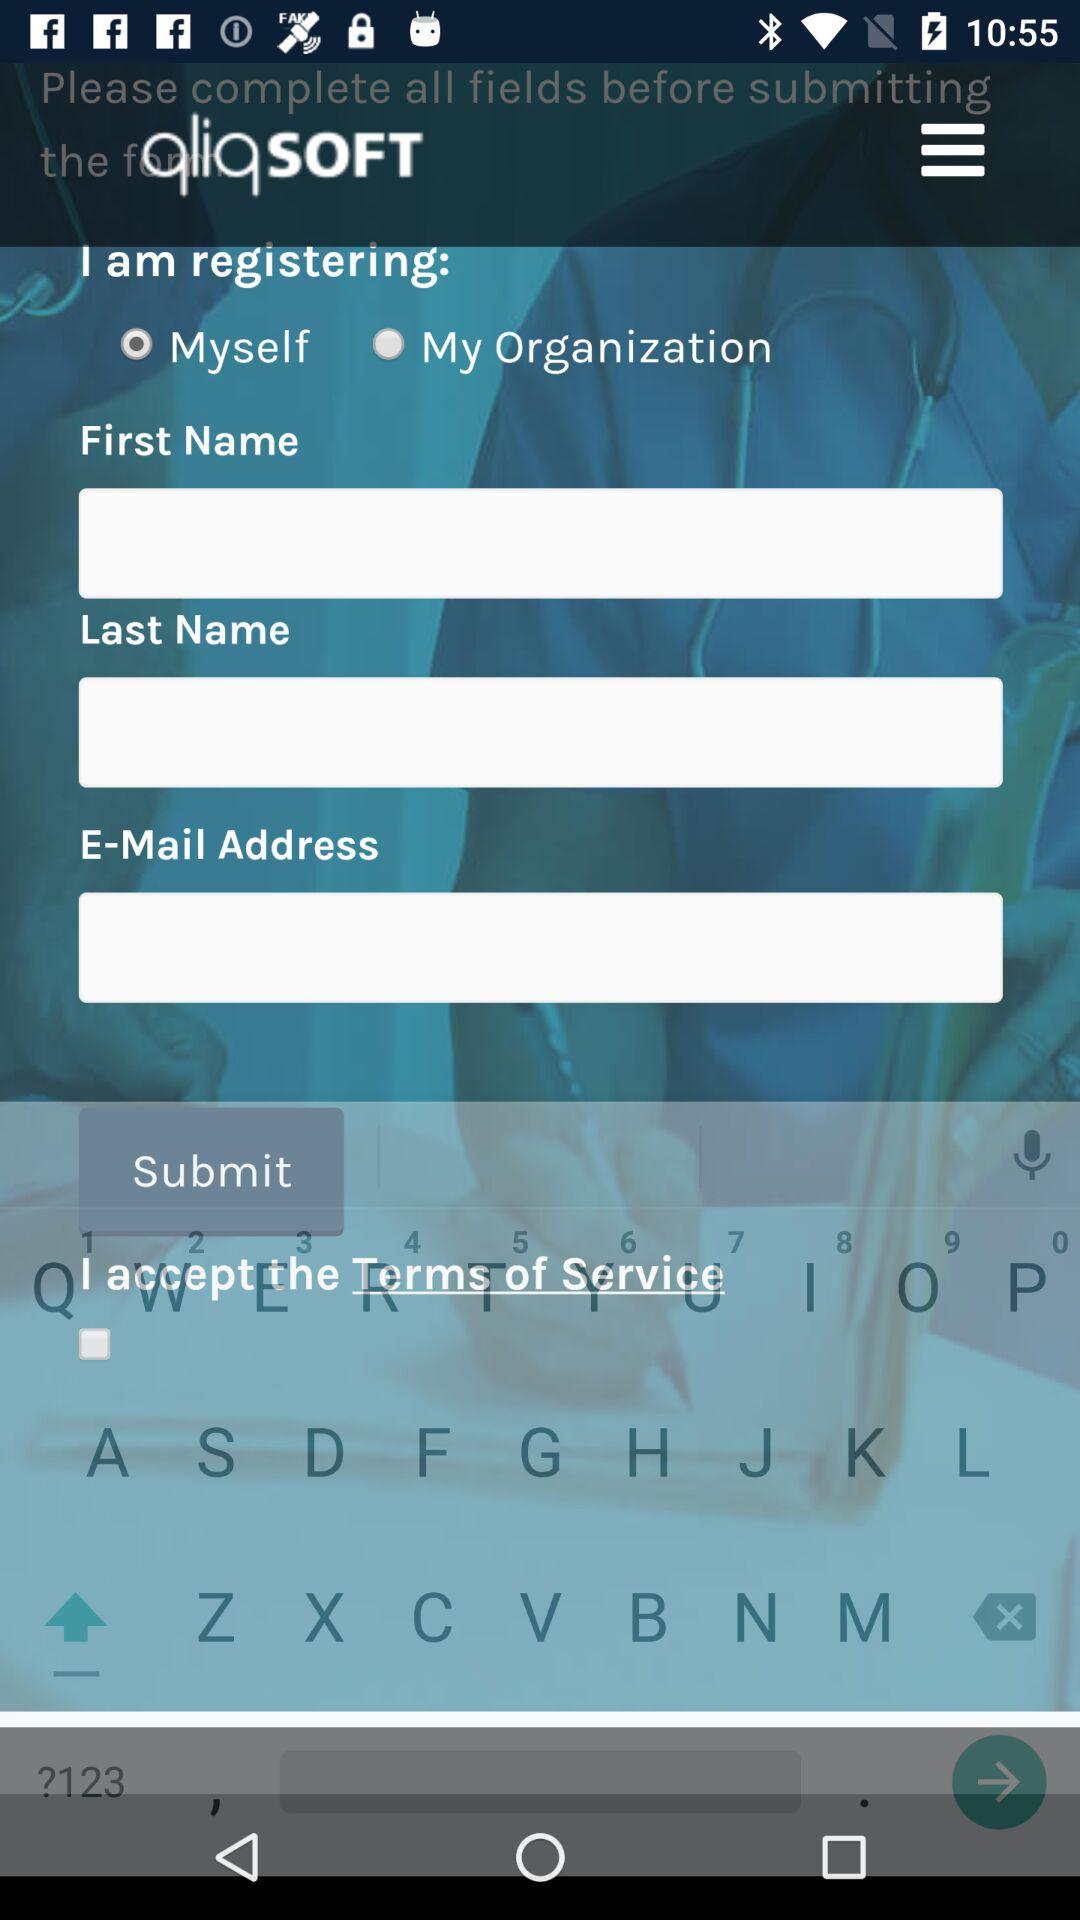What is the selected option for registering? The selected option is "Myself". 